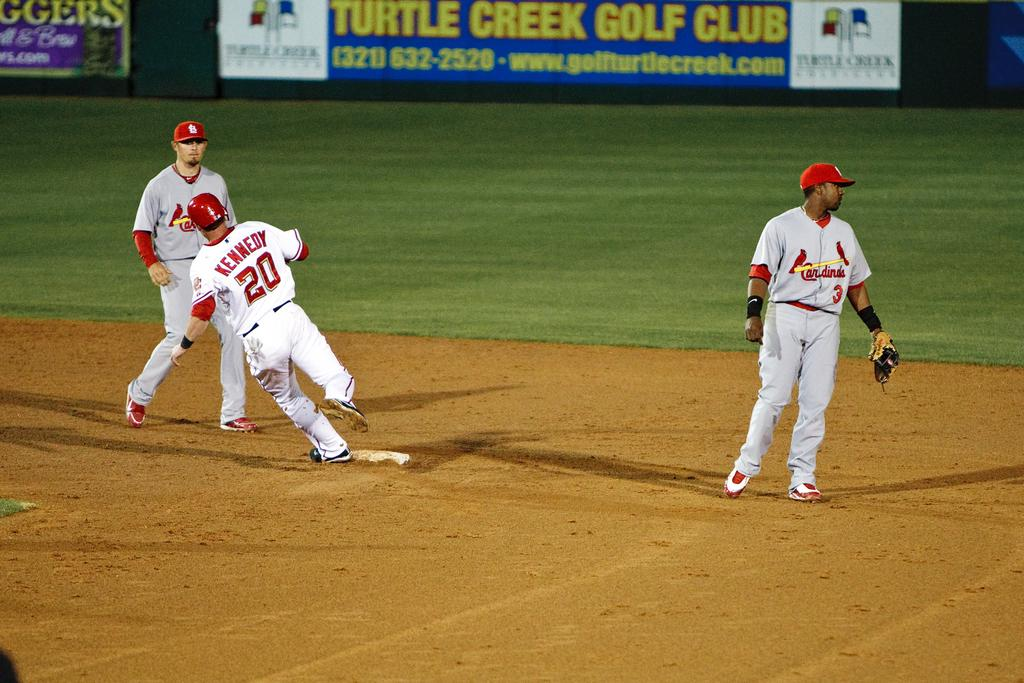<image>
Offer a succinct explanation of the picture presented. Three baseball players are in the middle of a game on a field bearing an advertisement for Turtle Creek Golf Club. 